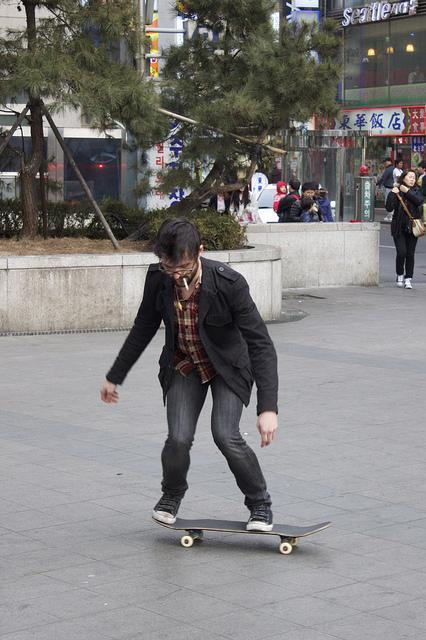What part of his body will be most harmed by the item in his mouth?
Pick the right solution, then justify: 'Answer: answer
Rationale: rationale.'
Options: Back, lungs, feet, eyes. Answer: lungs.
Rationale: Because cigarettes' are harmful to the body especially the lungs, as they result to chronic diseases. 